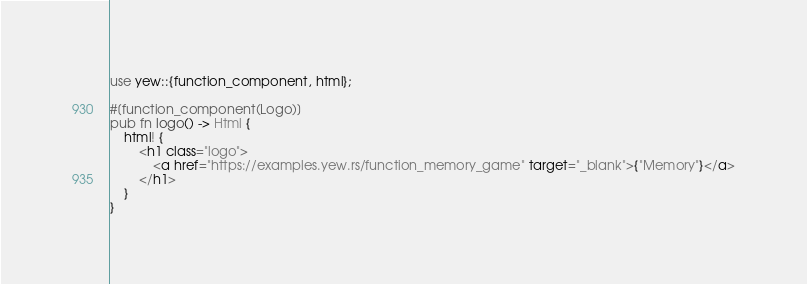<code> <loc_0><loc_0><loc_500><loc_500><_Rust_>use yew::{function_component, html};

#[function_component(Logo)]
pub fn logo() -> Html {
    html! {
        <h1 class="logo">
            <a href="https://examples.yew.rs/function_memory_game" target="_blank">{"Memory"}</a>
        </h1>
    }
}
</code> 